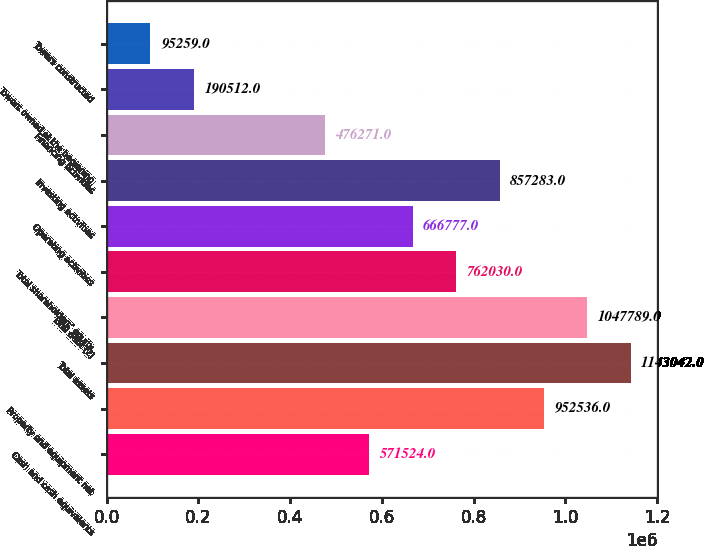Convert chart. <chart><loc_0><loc_0><loc_500><loc_500><bar_chart><fcel>Cash and cash equivalents<fcel>Property and equipment net<fcel>Total assets<fcel>Total debt (2)<fcel>Total shareholders' equity<fcel>Operating activities<fcel>Investing activities<fcel>Financing activities<fcel>Towers owned at the beginning<fcel>Towers constructed<nl><fcel>571524<fcel>952536<fcel>1.14304e+06<fcel>1.04779e+06<fcel>762030<fcel>666777<fcel>857283<fcel>476271<fcel>190512<fcel>95259<nl></chart> 